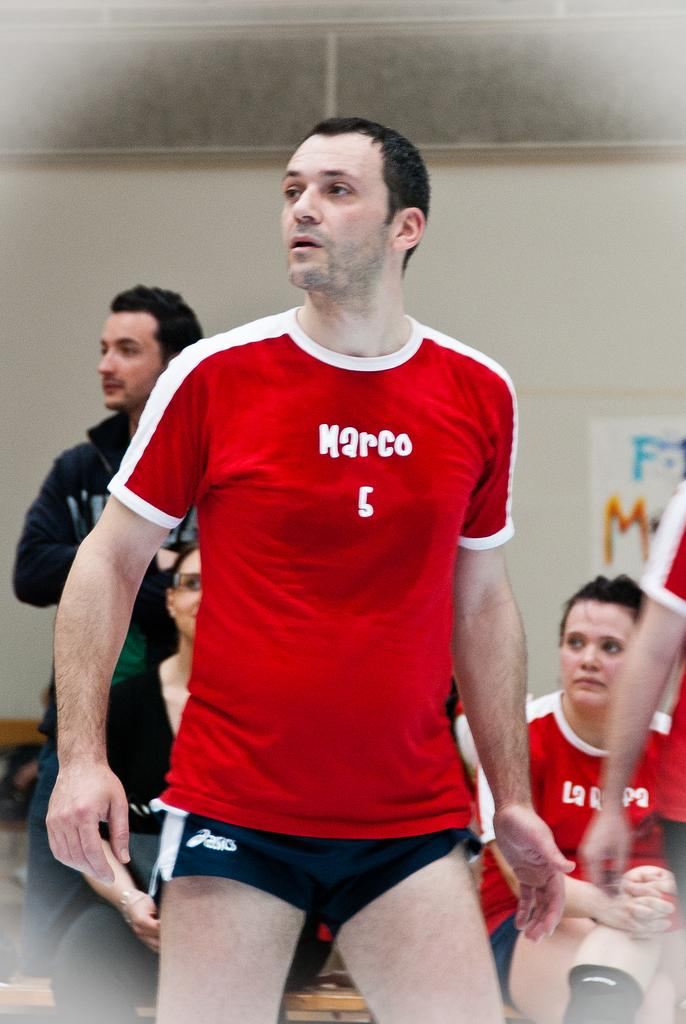<image>
Create a compact narrative representing the image presented. A guy in shorts is wearing a red shirt with the word Marco on it. 